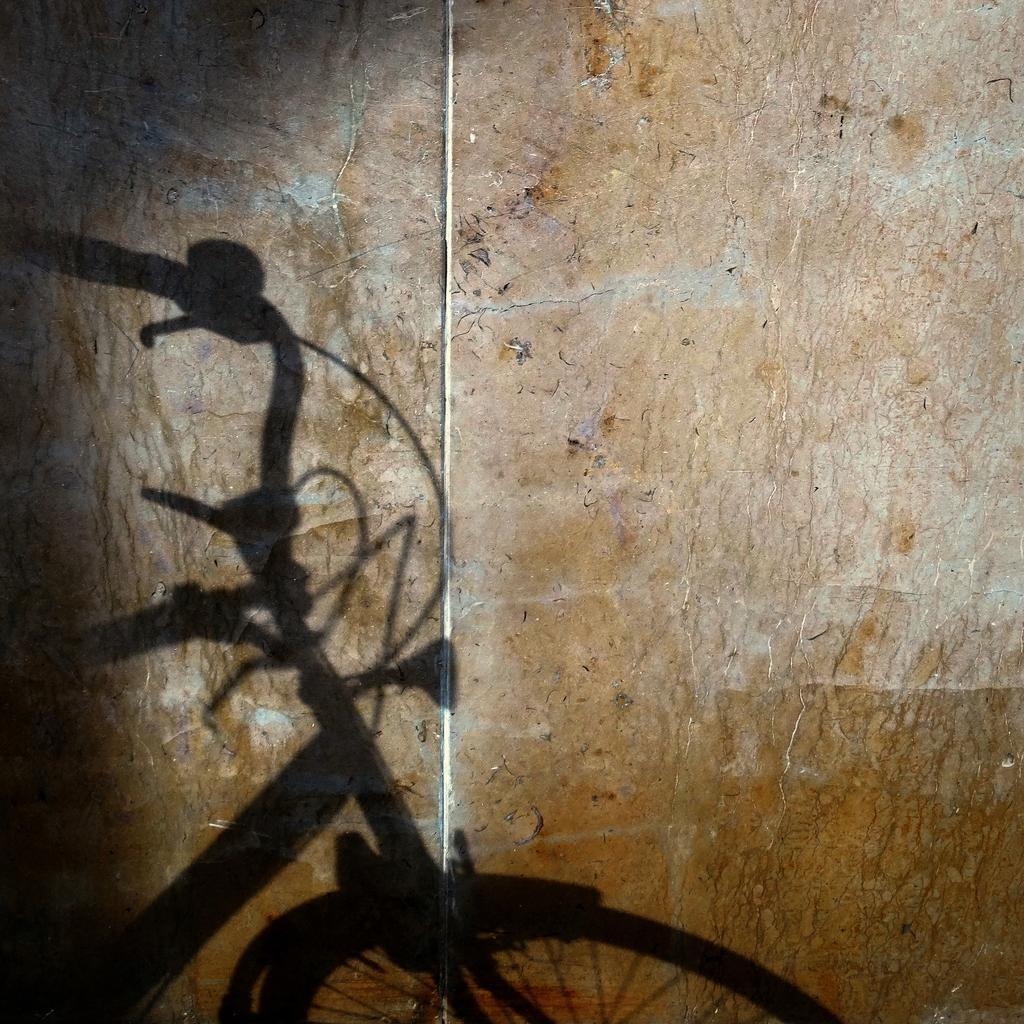In one or two sentences, can you explain what this image depicts? In this picture we can see shadow of a bicycle. 